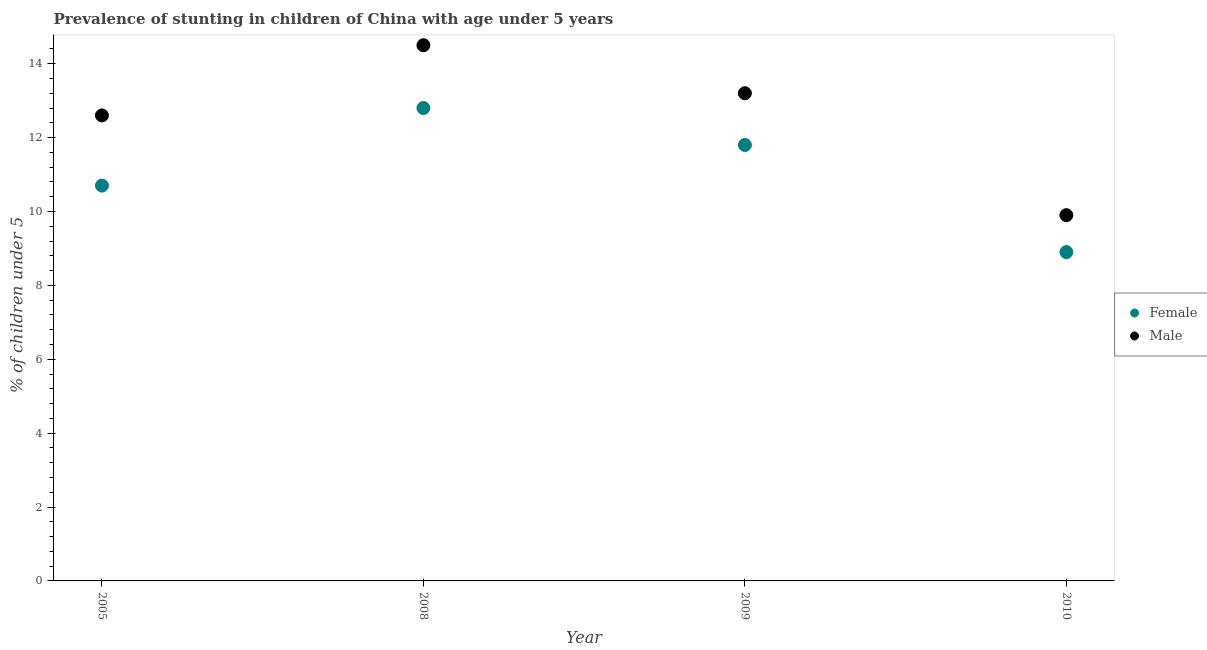How many different coloured dotlines are there?
Provide a succinct answer. 2. What is the percentage of stunted male children in 2009?
Make the answer very short. 13.2. Across all years, what is the minimum percentage of stunted female children?
Keep it short and to the point. 8.9. What is the total percentage of stunted female children in the graph?
Give a very brief answer. 44.2. What is the difference between the percentage of stunted female children in 2008 and that in 2010?
Give a very brief answer. 3.9. What is the difference between the percentage of stunted female children in 2008 and the percentage of stunted male children in 2009?
Ensure brevity in your answer.  -0.4. What is the average percentage of stunted female children per year?
Provide a short and direct response. 11.05. In the year 2008, what is the difference between the percentage of stunted female children and percentage of stunted male children?
Your answer should be compact. -1.7. In how many years, is the percentage of stunted male children greater than 2.4 %?
Offer a very short reply. 4. What is the ratio of the percentage of stunted male children in 2005 to that in 2008?
Your answer should be very brief. 0.87. Is the percentage of stunted female children in 2005 less than that in 2010?
Give a very brief answer. No. What is the difference between the highest and the lowest percentage of stunted female children?
Your answer should be very brief. 3.9. Does the percentage of stunted female children monotonically increase over the years?
Provide a succinct answer. No. Is the percentage of stunted male children strictly greater than the percentage of stunted female children over the years?
Your answer should be very brief. Yes. Is the percentage of stunted male children strictly less than the percentage of stunted female children over the years?
Make the answer very short. No. What is the difference between two consecutive major ticks on the Y-axis?
Make the answer very short. 2. How are the legend labels stacked?
Your answer should be compact. Vertical. What is the title of the graph?
Ensure brevity in your answer.  Prevalence of stunting in children of China with age under 5 years. Does "GDP at market prices" appear as one of the legend labels in the graph?
Your response must be concise. No. What is the label or title of the X-axis?
Your answer should be compact. Year. What is the label or title of the Y-axis?
Provide a short and direct response.  % of children under 5. What is the  % of children under 5 of Female in 2005?
Offer a very short reply. 10.7. What is the  % of children under 5 in Male in 2005?
Provide a short and direct response. 12.6. What is the  % of children under 5 of Female in 2008?
Offer a terse response. 12.8. What is the  % of children under 5 of Male in 2008?
Your answer should be very brief. 14.5. What is the  % of children under 5 of Female in 2009?
Provide a short and direct response. 11.8. What is the  % of children under 5 of Male in 2009?
Ensure brevity in your answer.  13.2. What is the  % of children under 5 of Female in 2010?
Make the answer very short. 8.9. What is the  % of children under 5 in Male in 2010?
Provide a short and direct response. 9.9. Across all years, what is the maximum  % of children under 5 in Female?
Offer a very short reply. 12.8. Across all years, what is the minimum  % of children under 5 of Female?
Provide a short and direct response. 8.9. Across all years, what is the minimum  % of children under 5 of Male?
Keep it short and to the point. 9.9. What is the total  % of children under 5 in Female in the graph?
Provide a succinct answer. 44.2. What is the total  % of children under 5 in Male in the graph?
Your response must be concise. 50.2. What is the difference between the  % of children under 5 of Female in 2005 and that in 2009?
Make the answer very short. -1.1. What is the difference between the  % of children under 5 of Female in 2005 and that in 2010?
Your answer should be very brief. 1.8. What is the difference between the  % of children under 5 of Male in 2005 and that in 2010?
Ensure brevity in your answer.  2.7. What is the difference between the  % of children under 5 in Female in 2008 and that in 2009?
Provide a succinct answer. 1. What is the difference between the  % of children under 5 in Male in 2008 and that in 2009?
Keep it short and to the point. 1.3. What is the difference between the  % of children under 5 of Female in 2008 and that in 2010?
Provide a short and direct response. 3.9. What is the difference between the  % of children under 5 in Female in 2009 and that in 2010?
Your response must be concise. 2.9. What is the difference between the  % of children under 5 in Female in 2008 and the  % of children under 5 in Male in 2009?
Offer a very short reply. -0.4. What is the average  % of children under 5 in Female per year?
Give a very brief answer. 11.05. What is the average  % of children under 5 of Male per year?
Provide a short and direct response. 12.55. In the year 2005, what is the difference between the  % of children under 5 of Female and  % of children under 5 of Male?
Your response must be concise. -1.9. In the year 2008, what is the difference between the  % of children under 5 of Female and  % of children under 5 of Male?
Give a very brief answer. -1.7. In the year 2009, what is the difference between the  % of children under 5 of Female and  % of children under 5 of Male?
Give a very brief answer. -1.4. In the year 2010, what is the difference between the  % of children under 5 of Female and  % of children under 5 of Male?
Give a very brief answer. -1. What is the ratio of the  % of children under 5 in Female in 2005 to that in 2008?
Offer a very short reply. 0.84. What is the ratio of the  % of children under 5 of Male in 2005 to that in 2008?
Give a very brief answer. 0.87. What is the ratio of the  % of children under 5 in Female in 2005 to that in 2009?
Your answer should be very brief. 0.91. What is the ratio of the  % of children under 5 in Male in 2005 to that in 2009?
Your answer should be very brief. 0.95. What is the ratio of the  % of children under 5 of Female in 2005 to that in 2010?
Give a very brief answer. 1.2. What is the ratio of the  % of children under 5 in Male in 2005 to that in 2010?
Offer a very short reply. 1.27. What is the ratio of the  % of children under 5 of Female in 2008 to that in 2009?
Your answer should be compact. 1.08. What is the ratio of the  % of children under 5 of Male in 2008 to that in 2009?
Ensure brevity in your answer.  1.1. What is the ratio of the  % of children under 5 in Female in 2008 to that in 2010?
Provide a short and direct response. 1.44. What is the ratio of the  % of children under 5 of Male in 2008 to that in 2010?
Offer a terse response. 1.46. What is the ratio of the  % of children under 5 of Female in 2009 to that in 2010?
Your response must be concise. 1.33. What is the ratio of the  % of children under 5 in Male in 2009 to that in 2010?
Your answer should be very brief. 1.33. What is the difference between the highest and the second highest  % of children under 5 in Male?
Keep it short and to the point. 1.3. What is the difference between the highest and the lowest  % of children under 5 in Female?
Ensure brevity in your answer.  3.9. 